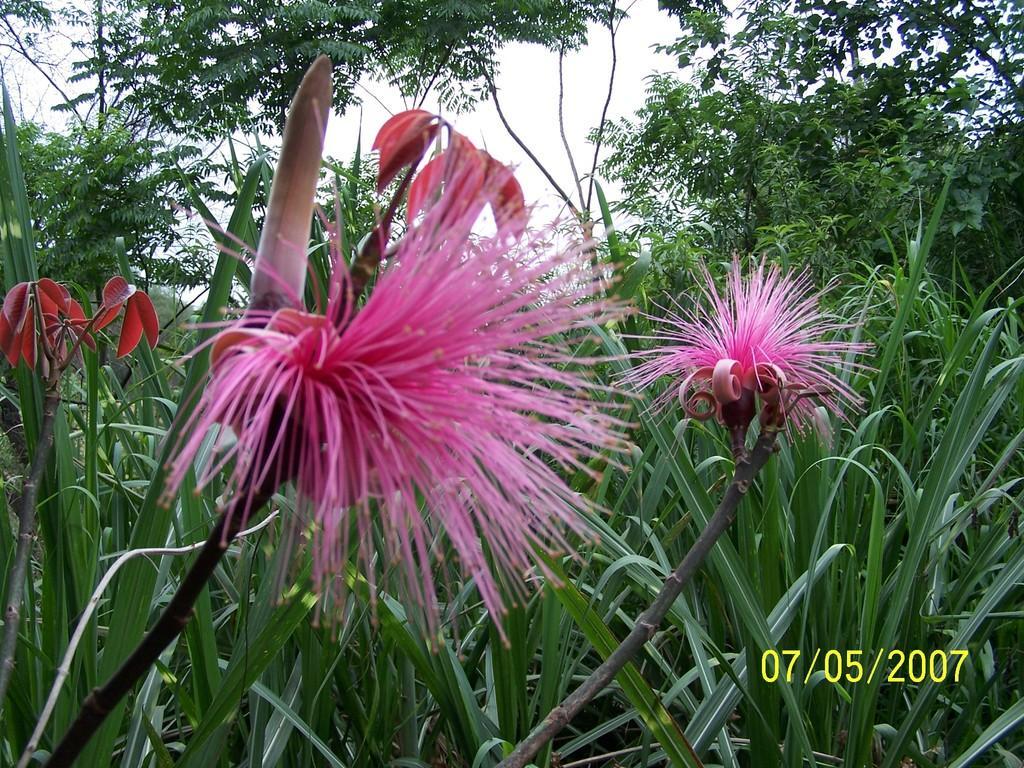In one or two sentences, can you explain what this image depicts? Here in this picture we can see flowers present on the plants over there and behind that we can also see trees present all over there. 